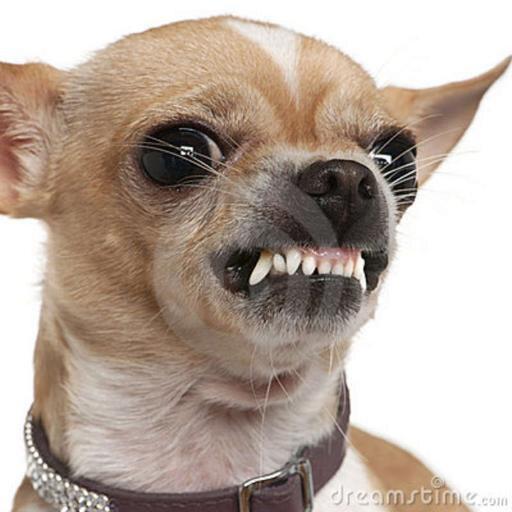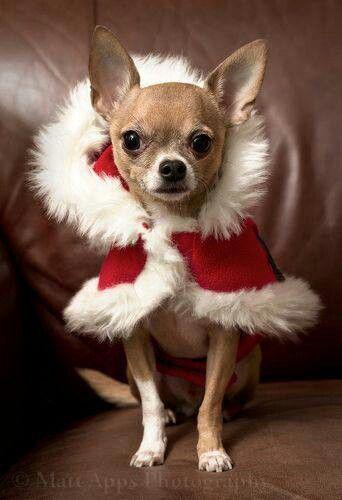The first image is the image on the left, the second image is the image on the right. For the images shown, is this caption "A chihuahua is wearing an article of clothing int he right image." true? Answer yes or no. Yes. The first image is the image on the left, the second image is the image on the right. Considering the images on both sides, is "The left image features a fang-bearing chihuahua, and the right image features a chihuhua in costume-like get-up." valid? Answer yes or no. Yes. 